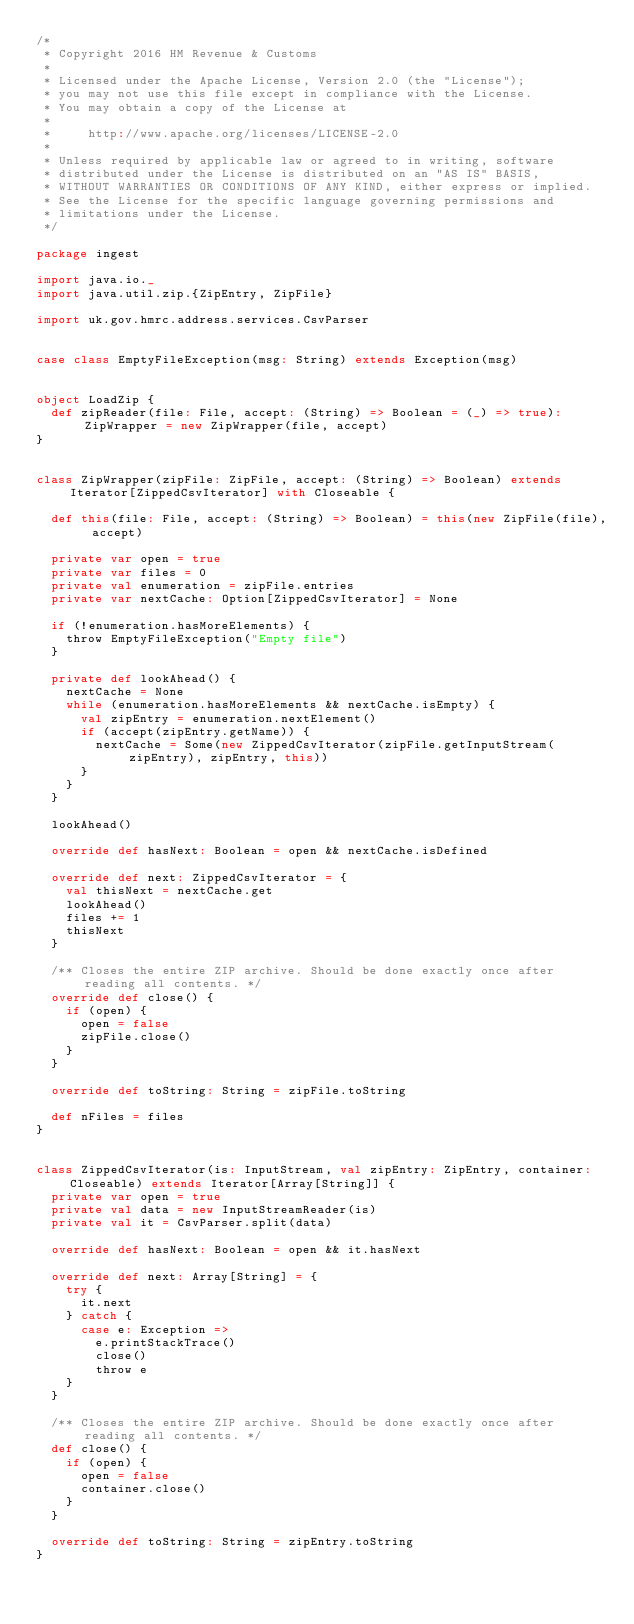<code> <loc_0><loc_0><loc_500><loc_500><_Scala_>/*
 * Copyright 2016 HM Revenue & Customs
 *
 * Licensed under the Apache License, Version 2.0 (the "License");
 * you may not use this file except in compliance with the License.
 * You may obtain a copy of the License at
 *
 *     http://www.apache.org/licenses/LICENSE-2.0
 *
 * Unless required by applicable law or agreed to in writing, software
 * distributed under the License is distributed on an "AS IS" BASIS,
 * WITHOUT WARRANTIES OR CONDITIONS OF ANY KIND, either express or implied.
 * See the License for the specific language governing permissions and
 * limitations under the License.
 */

package ingest

import java.io._
import java.util.zip.{ZipEntry, ZipFile}

import uk.gov.hmrc.address.services.CsvParser


case class EmptyFileException(msg: String) extends Exception(msg)


object LoadZip {
  def zipReader(file: File, accept: (String) => Boolean = (_) => true): ZipWrapper = new ZipWrapper(file, accept)
}


class ZipWrapper(zipFile: ZipFile, accept: (String) => Boolean) extends Iterator[ZippedCsvIterator] with Closeable {

  def this(file: File, accept: (String) => Boolean) = this(new ZipFile(file), accept)

  private var open = true
  private var files = 0
  private val enumeration = zipFile.entries
  private var nextCache: Option[ZippedCsvIterator] = None

  if (!enumeration.hasMoreElements) {
    throw EmptyFileException("Empty file")
  }

  private def lookAhead() {
    nextCache = None
    while (enumeration.hasMoreElements && nextCache.isEmpty) {
      val zipEntry = enumeration.nextElement()
      if (accept(zipEntry.getName)) {
        nextCache = Some(new ZippedCsvIterator(zipFile.getInputStream(zipEntry), zipEntry, this))
      }
    }
  }

  lookAhead()

  override def hasNext: Boolean = open && nextCache.isDefined

  override def next: ZippedCsvIterator = {
    val thisNext = nextCache.get
    lookAhead()
    files += 1
    thisNext
  }

  /** Closes the entire ZIP archive. Should be done exactly once after reading all contents. */
  override def close() {
    if (open) {
      open = false
      zipFile.close()
    }
  }

  override def toString: String = zipFile.toString

  def nFiles = files
}


class ZippedCsvIterator(is: InputStream, val zipEntry: ZipEntry, container: Closeable) extends Iterator[Array[String]] {
  private var open = true
  private val data = new InputStreamReader(is)
  private val it = CsvParser.split(data)

  override def hasNext: Boolean = open && it.hasNext

  override def next: Array[String] = {
    try {
      it.next
    } catch {
      case e: Exception =>
        e.printStackTrace()
        close()
        throw e
    }
  }

  /** Closes the entire ZIP archive. Should be done exactly once after reading all contents. */
  def close() {
    if (open) {
      open = false
      container.close()
    }
  }

  override def toString: String = zipEntry.toString
}
</code> 